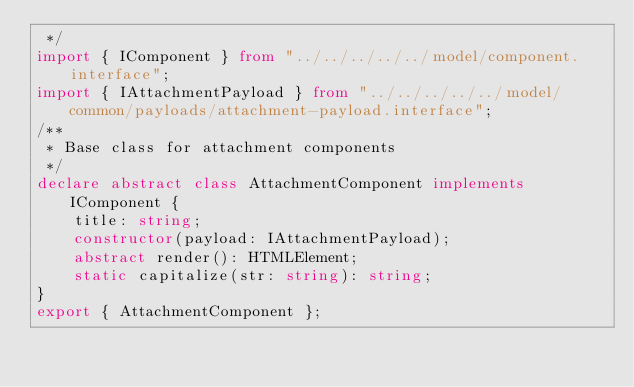<code> <loc_0><loc_0><loc_500><loc_500><_TypeScript_> */
import { IComponent } from "../../../../../model/component.interface";
import { IAttachmentPayload } from "../../../../../model/common/payloads/attachment-payload.interface";
/**
 * Base class for attachment components
 */
declare abstract class AttachmentComponent implements IComponent {
    title: string;
    constructor(payload: IAttachmentPayload);
    abstract render(): HTMLElement;
    static capitalize(str: string): string;
}
export { AttachmentComponent };
</code> 